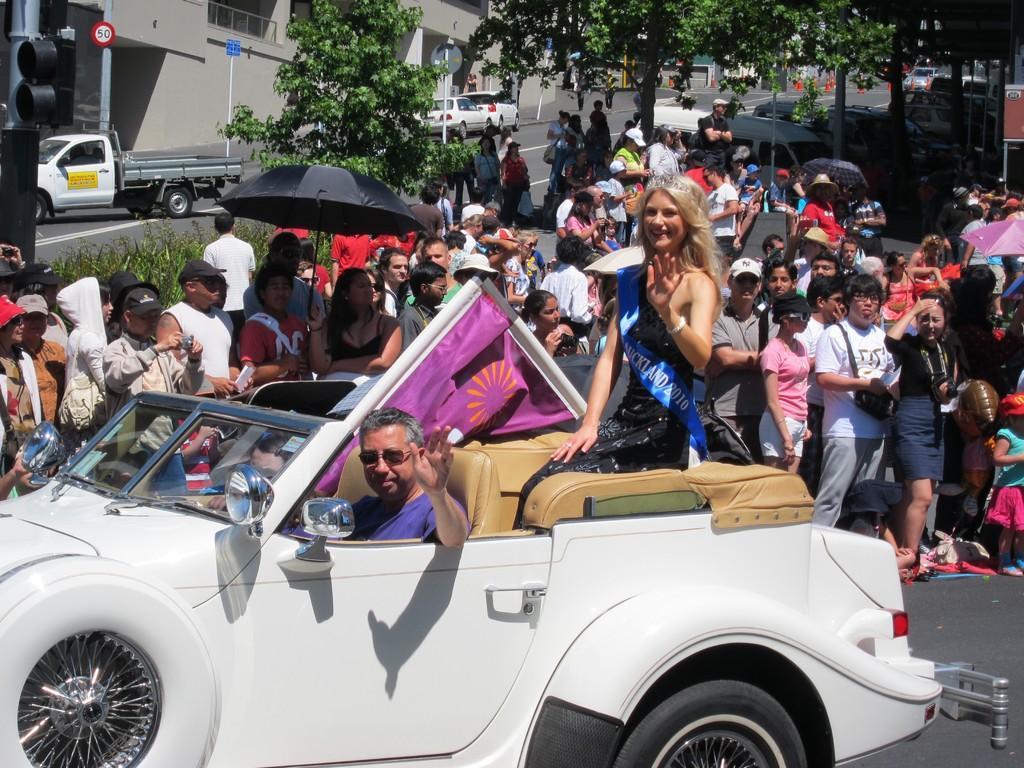Describe this image in one or two sentences. In this picture we can see group of people standing. In front of these people we can see vehicle. Inside the vehicle there are three persons. In this background we can see wall,some vehicles on the road. There are few trees. There is a pole. This person holding umbrella. 